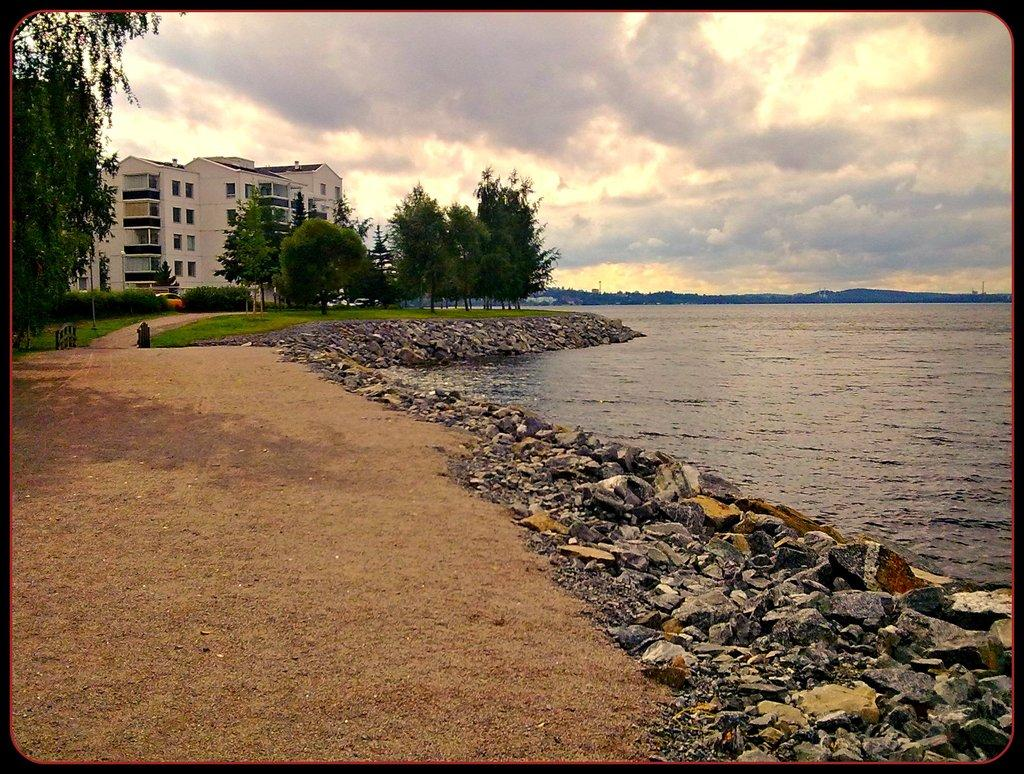What type of surface is visible in the image? There is ground in the image. What objects can be seen on the ground? There are stones in the image. What natural element is present in the image? There is water in the image. What can be seen in the distance in the image? There are trees, buildings, and walls in the background of the image. How is the sky depicted in the image? The sky is cloudy in the background of the image. How many balls are being juggled by the deer in the image? There is no deer or balls present in the image. 